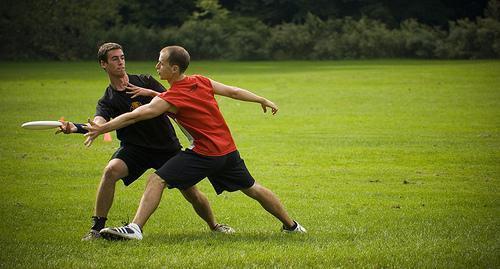How many people are in the photo?
Give a very brief answer. 2. 